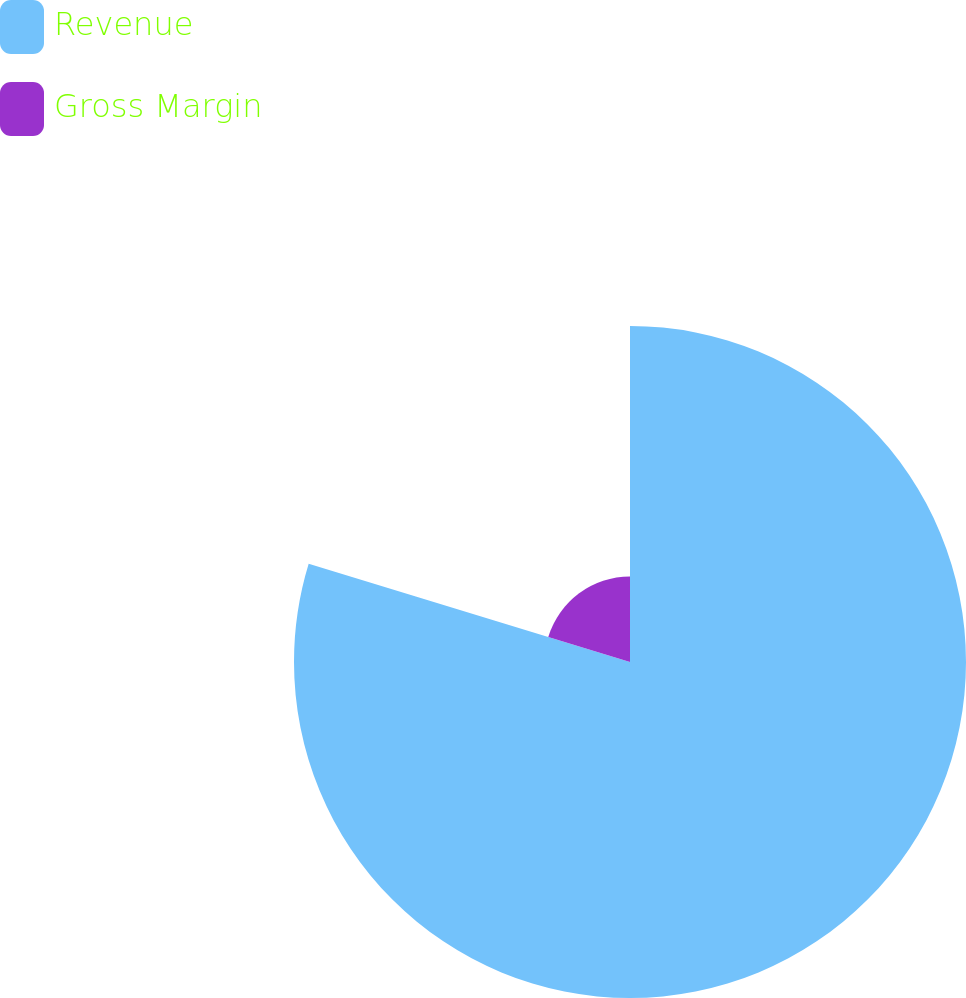Convert chart. <chart><loc_0><loc_0><loc_500><loc_500><pie_chart><fcel>Revenue<fcel>Gross Margin<nl><fcel>79.72%<fcel>20.28%<nl></chart> 